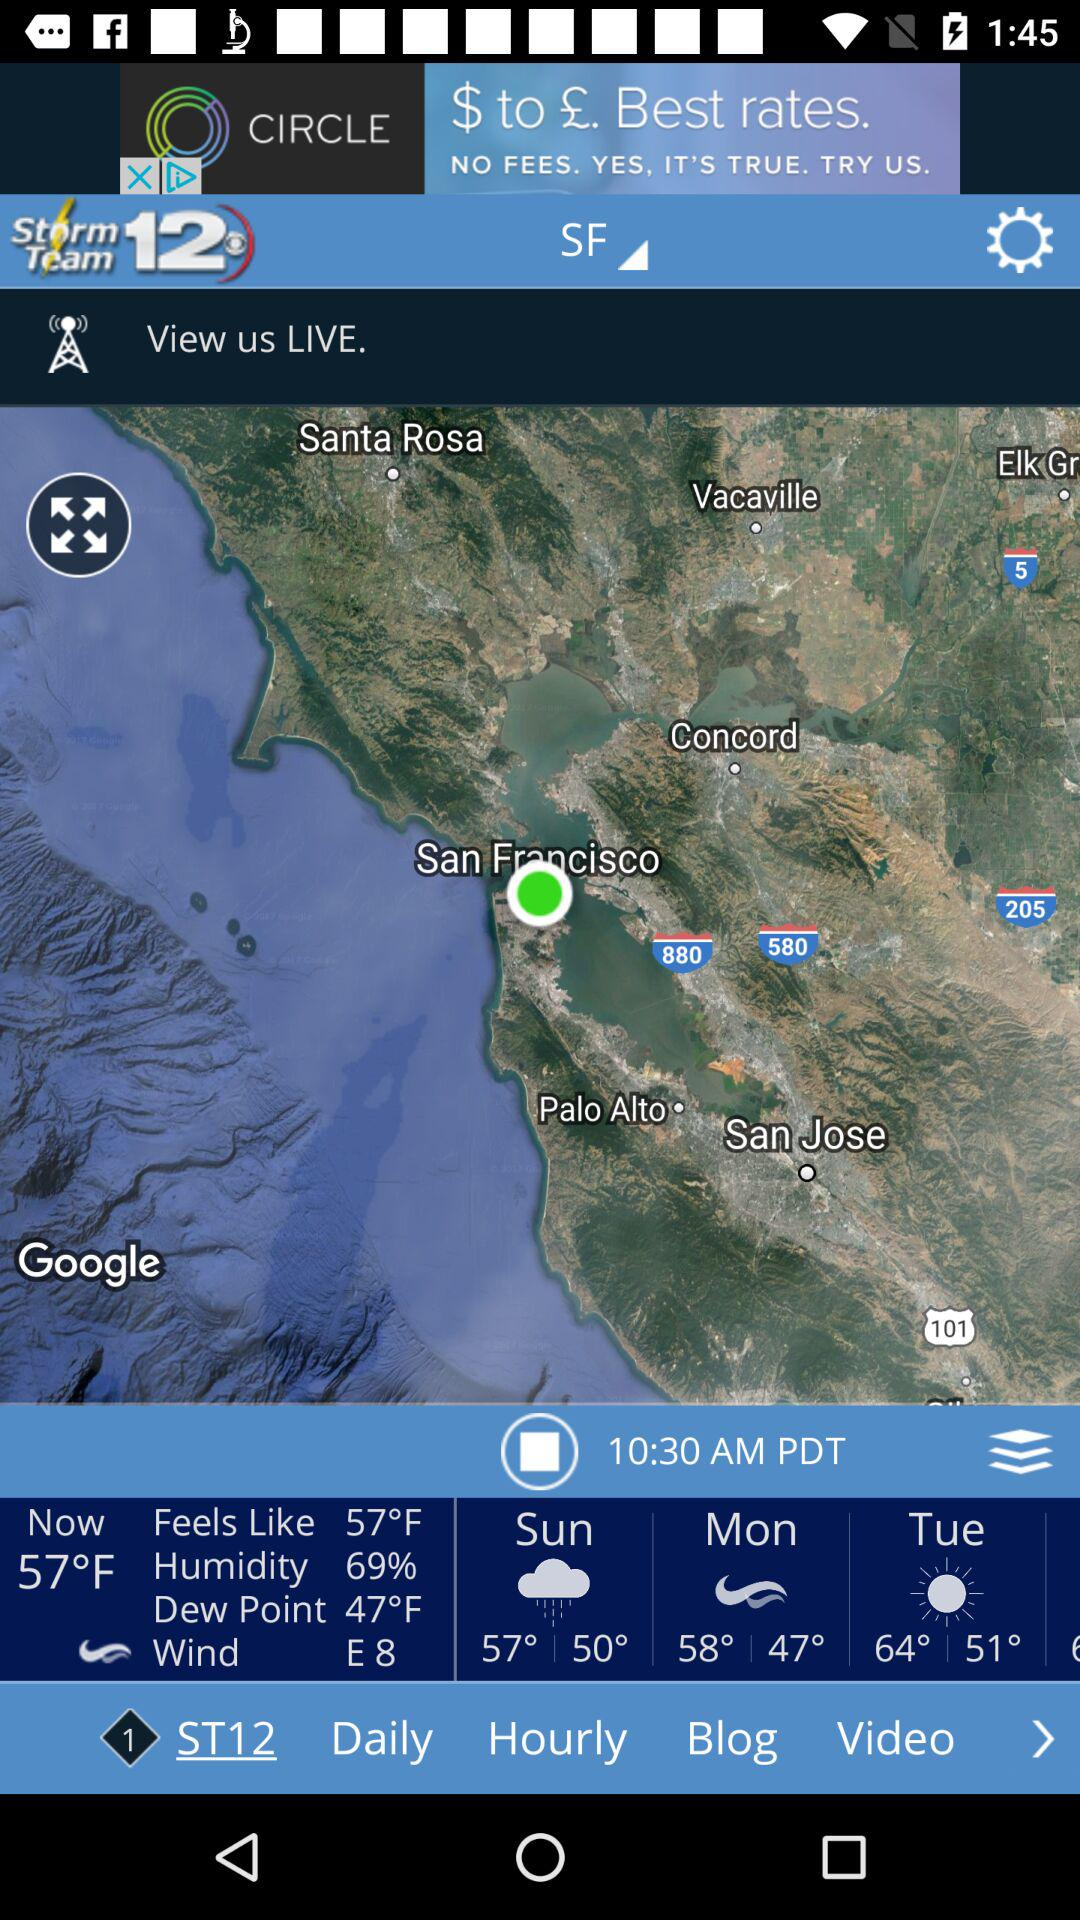What is the wind direction?
Answer the question using a single word or phrase. E 